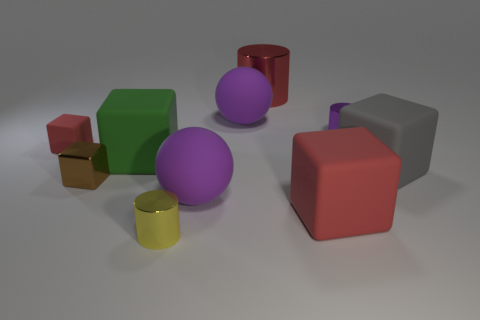Subtract all large red blocks. How many blocks are left? 4 Subtract all spheres. How many objects are left? 8 Subtract 1 spheres. How many spheres are left? 1 Add 5 brown shiny cubes. How many brown shiny cubes are left? 6 Add 7 green matte things. How many green matte things exist? 8 Subtract all yellow cylinders. How many cylinders are left? 2 Subtract 1 red cylinders. How many objects are left? 9 Subtract all red spheres. Subtract all purple cylinders. How many spheres are left? 2 Subtract all green cubes. How many purple cylinders are left? 1 Subtract all large gray spheres. Subtract all big blocks. How many objects are left? 7 